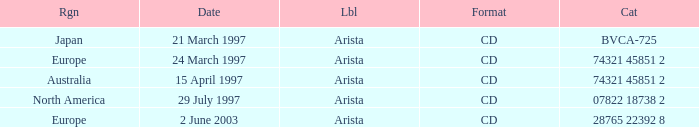What's the Date for the Region of Europe and has the Catalog of 28765 22392 8? 2 June 2003. 